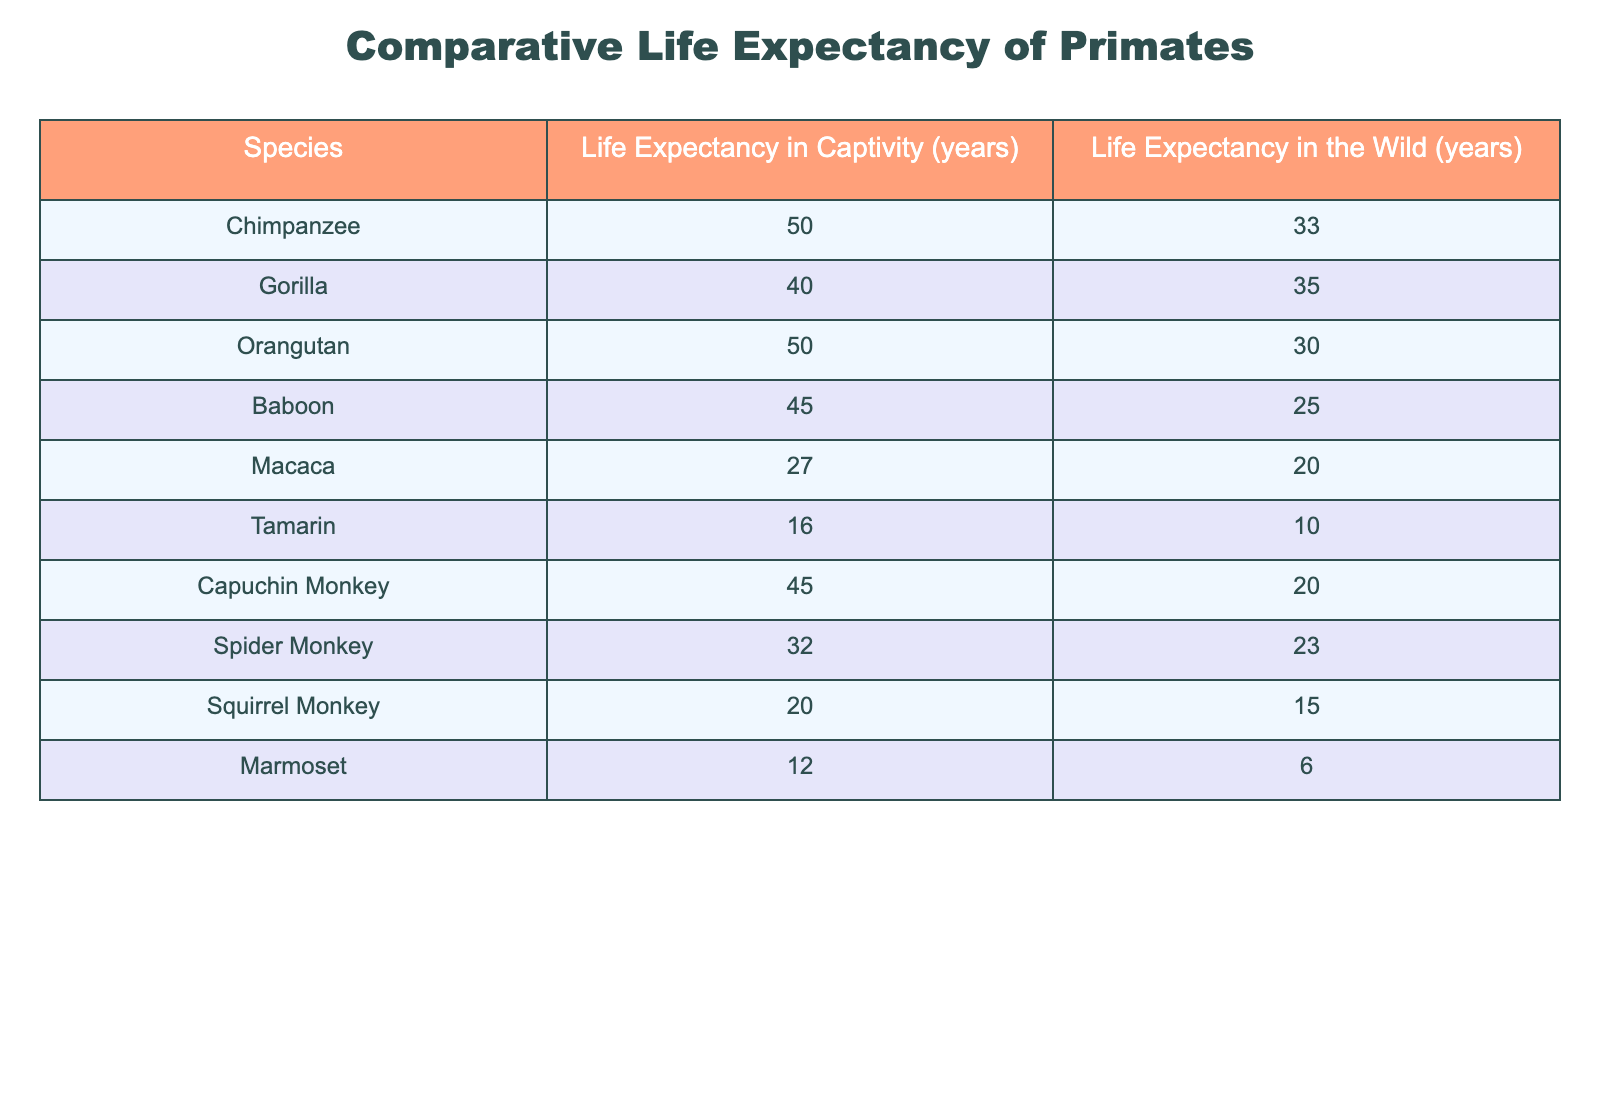What is the life expectancy of chimpanzees in captivity? The table clearly states that the life expectancy of chimpanzees in captivity is 50 years.
Answer: 50 years How much longer do chimpanzees live in captivity compared to the wild? To find the difference, subtract the life expectancy in the wild (33 years) from the life expectancy in captivity (50 years): 50 - 33 = 17 years.
Answer: 17 years What is the average life expectancy of gorillas? The life expectancy in captivity is 40 years and in the wild is 35 years, so the average can be calculated by adding 40 + 35 = 75 and dividing by the number of conditions (2): 75 / 2 = 37.5 years.
Answer: 37.5 years Do tamarins have a longer life expectancy in captivity than in the wild? According to the table, tamarins live 16 years in captivity and 10 years in the wild, which shows the life expectancy in captivity is higher.
Answer: Yes Which primate has the smallest difference in life expectancy between captivity and the wild? Calculate the difference for each species: Chimpanzee (17), Gorilla (5), Orangutan (20), Baboon (20), Macaca (7), Tamarin (6), Capuchin Monkey (25), Spider Monkey (9), Squirrel Monkey (5), Marmoset (6). The smallest difference is 5 years for both gorillas and squirrel monkeys.
Answer: Gorilla and Squirrel Monkey (5 years) What species of primate lives the longest in captivity? The table indicates that chimpanzees and orangutans both live the longest in captivity, reaching 50 years.
Answer: Chimpanzees and Orangutans Is the life expectancy of capuchin monkeys in captivity higher than both tamarins and squirrel monkeys? In the table, capuchin monkeys live 45 years in captivity, tamarins 16 years, and squirrel monkeys 20 years. Since 45 is greater than both 16 and 20, this statement is true.
Answer: Yes What percentage of life expectancy in the wild do gorillas achieve compared to their life expectancy in captivity? Gorillas live 40 years in captivity and 35 years in the wild. The percentage can be calculated as (35 / 40) * 100 = 87.5%.
Answer: 87.5% 